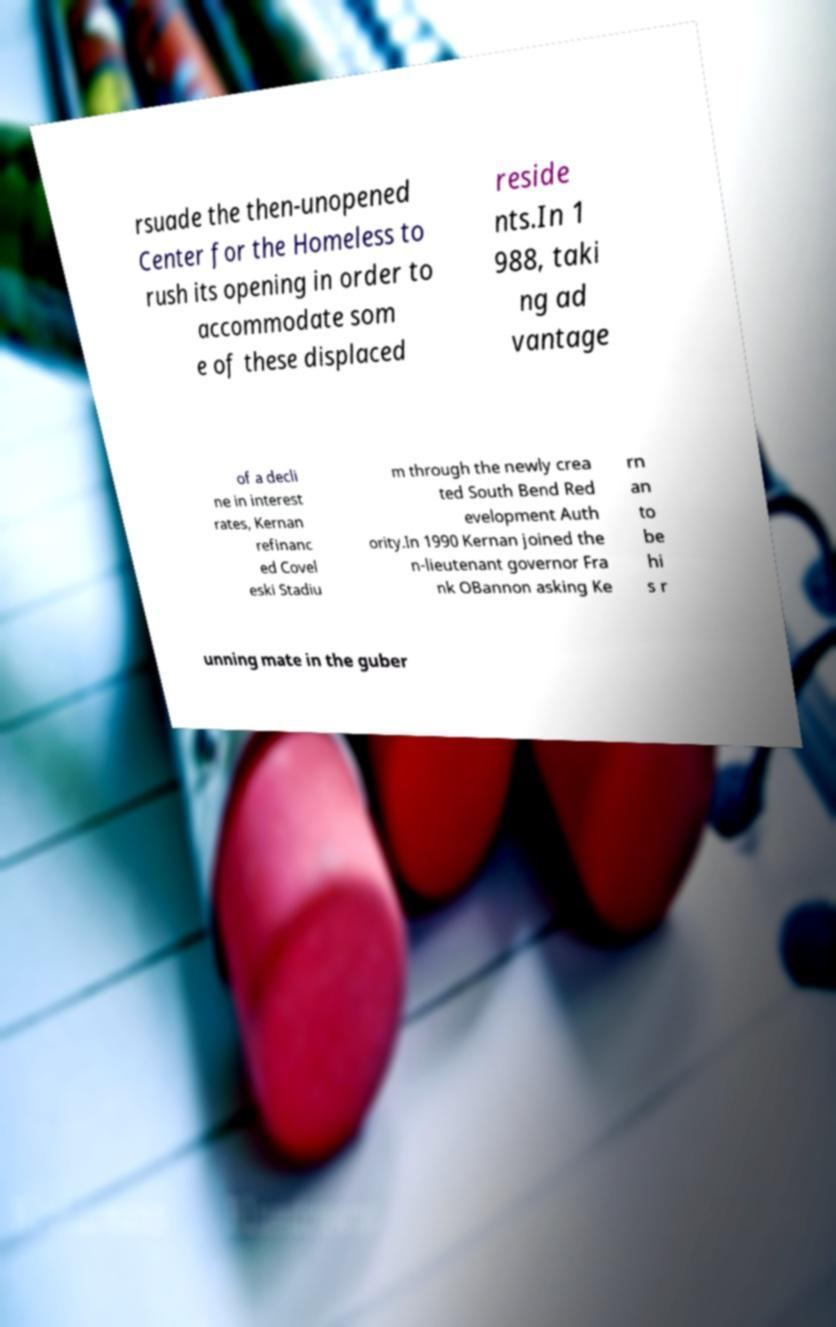Can you read and provide the text displayed in the image?This photo seems to have some interesting text. Can you extract and type it out for me? rsuade the then-unopened Center for the Homeless to rush its opening in order to accommodate som e of these displaced reside nts.In 1 988, taki ng ad vantage of a decli ne in interest rates, Kernan refinanc ed Covel eski Stadiu m through the newly crea ted South Bend Red evelopment Auth ority.In 1990 Kernan joined the n-lieutenant governor Fra nk OBannon asking Ke rn an to be hi s r unning mate in the guber 